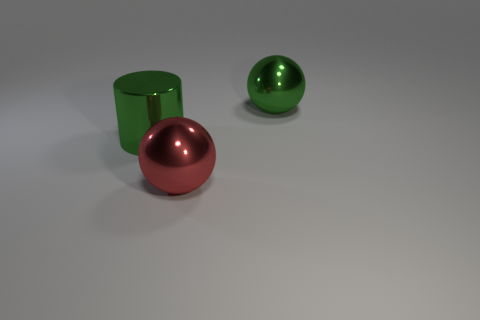How do the colors of the objects interact with each other? The colors of the objects—green and red—are complementary, which means they are opposite each other on the color wheel. This creates a visually striking contrast. The green objects being different shades, provide a sense of variation, while the consistent color of the shiny red ball brings a sense of cohesion to the scene. 